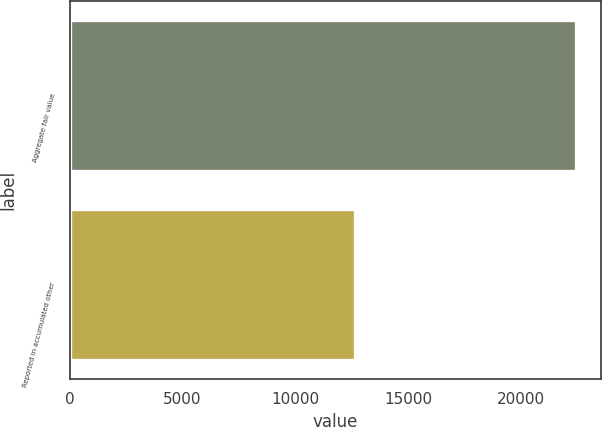<chart> <loc_0><loc_0><loc_500><loc_500><bar_chart><fcel>Aggregate fair value<fcel>Reported in accumulated other<nl><fcel>22416<fcel>12614<nl></chart> 